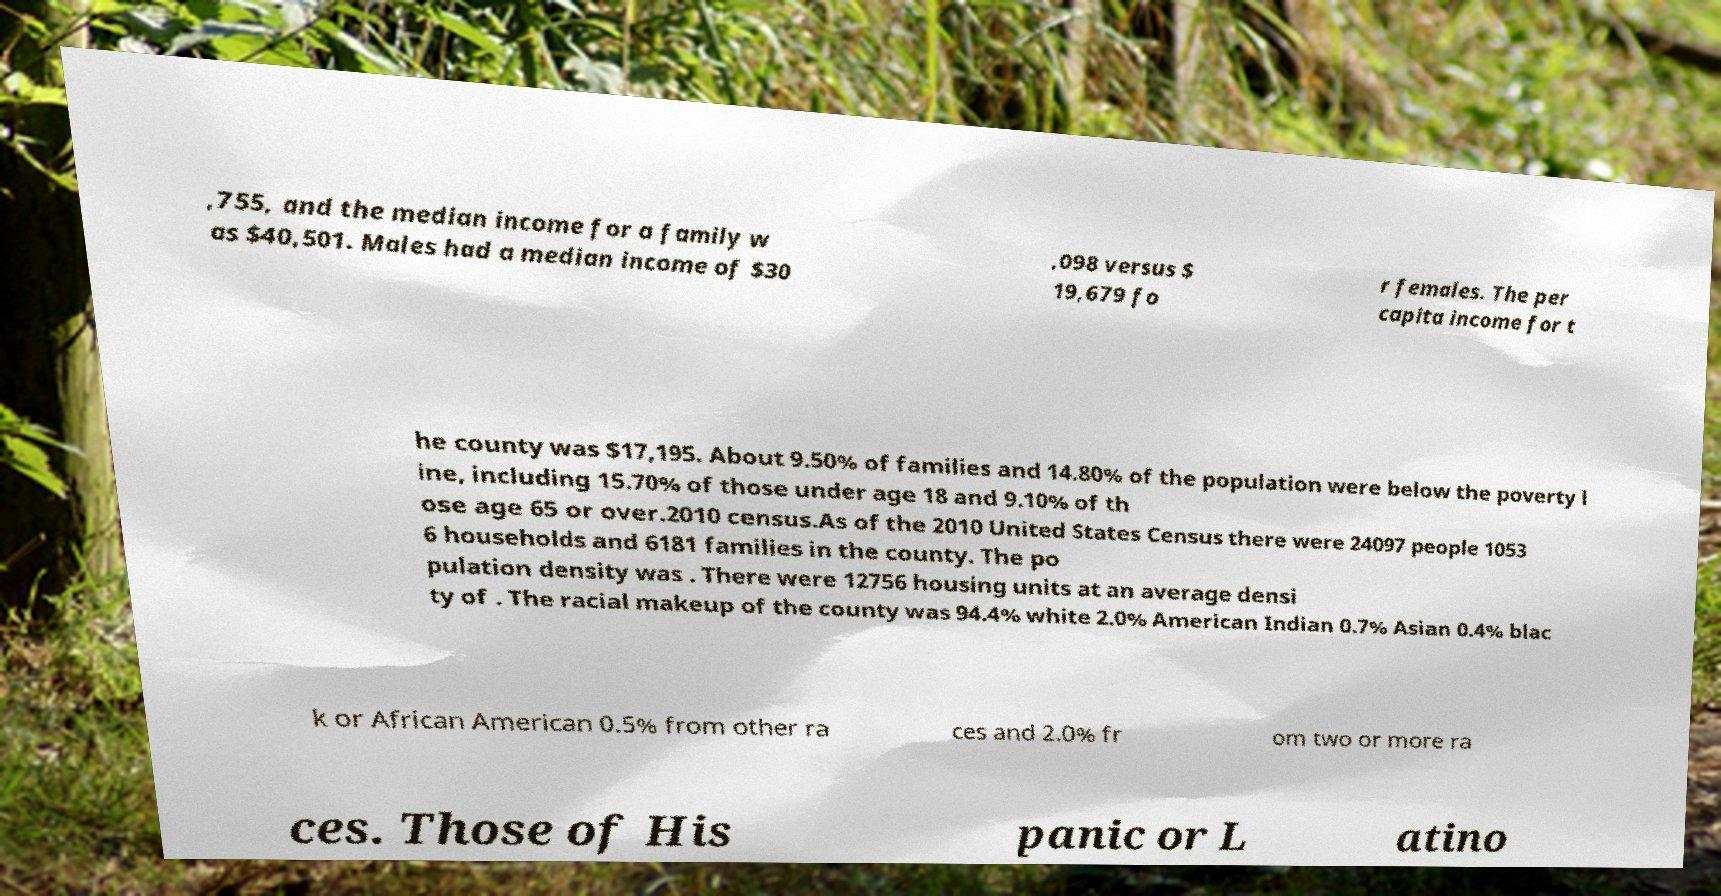Please identify and transcribe the text found in this image. ,755, and the median income for a family w as $40,501. Males had a median income of $30 ,098 versus $ 19,679 fo r females. The per capita income for t he county was $17,195. About 9.50% of families and 14.80% of the population were below the poverty l ine, including 15.70% of those under age 18 and 9.10% of th ose age 65 or over.2010 census.As of the 2010 United States Census there were 24097 people 1053 6 households and 6181 families in the county. The po pulation density was . There were 12756 housing units at an average densi ty of . The racial makeup of the county was 94.4% white 2.0% American Indian 0.7% Asian 0.4% blac k or African American 0.5% from other ra ces and 2.0% fr om two or more ra ces. Those of His panic or L atino 